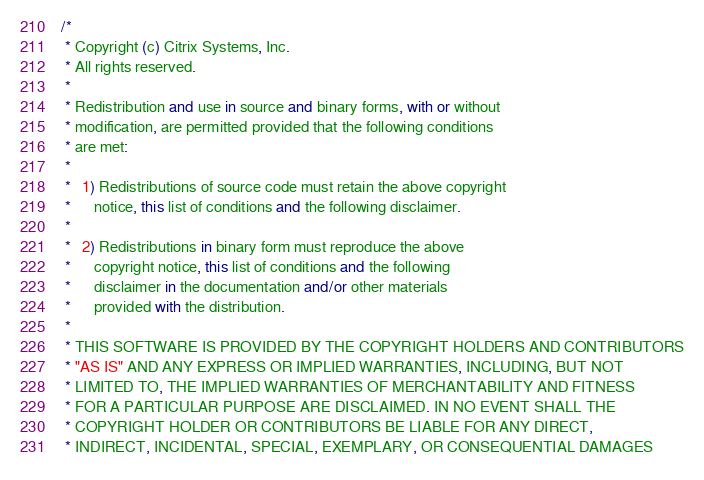Convert code to text. <code><loc_0><loc_0><loc_500><loc_500><_C#_>/*
 * Copyright (c) Citrix Systems, Inc.
 * All rights reserved.
 *
 * Redistribution and use in source and binary forms, with or without
 * modification, are permitted provided that the following conditions
 * are met:
 *
 *   1) Redistributions of source code must retain the above copyright
 *      notice, this list of conditions and the following disclaimer.
 *
 *   2) Redistributions in binary form must reproduce the above
 *      copyright notice, this list of conditions and the following
 *      disclaimer in the documentation and/or other materials
 *      provided with the distribution.
 *
 * THIS SOFTWARE IS PROVIDED BY THE COPYRIGHT HOLDERS AND CONTRIBUTORS
 * "AS IS" AND ANY EXPRESS OR IMPLIED WARRANTIES, INCLUDING, BUT NOT
 * LIMITED TO, THE IMPLIED WARRANTIES OF MERCHANTABILITY AND FITNESS
 * FOR A PARTICULAR PURPOSE ARE DISCLAIMED. IN NO EVENT SHALL THE
 * COPYRIGHT HOLDER OR CONTRIBUTORS BE LIABLE FOR ANY DIRECT,
 * INDIRECT, INCIDENTAL, SPECIAL, EXEMPLARY, OR CONSEQUENTIAL DAMAGES</code> 